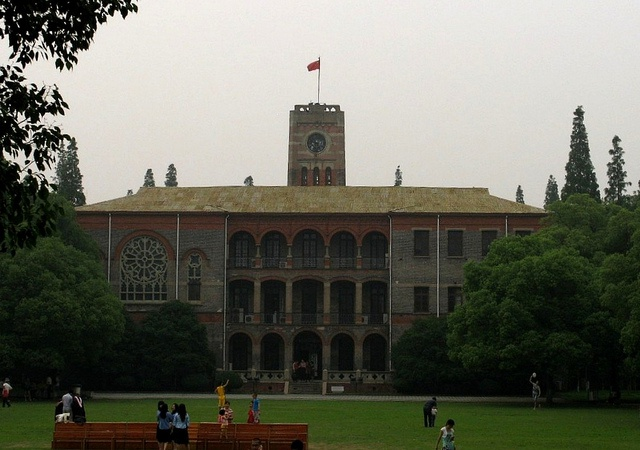Describe the objects in this image and their specific colors. I can see bench in black, maroon, darkgreen, and olive tones, people in black, navy, gray, and blue tones, people in black, darkgreen, and gray tones, people in black, blue, gray, and darkblue tones, and people in black, gray, and darkgreen tones in this image. 